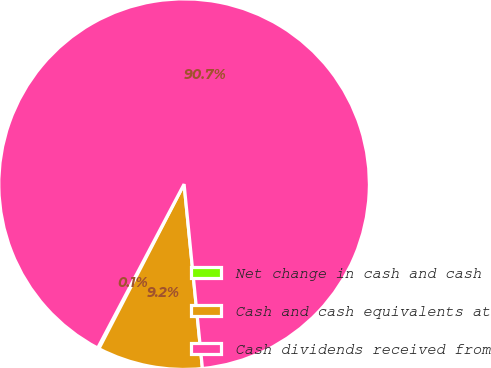Convert chart to OTSL. <chart><loc_0><loc_0><loc_500><loc_500><pie_chart><fcel>Net change in cash and cash<fcel>Cash and cash equivalents at<fcel>Cash dividends received from<nl><fcel>0.12%<fcel>9.18%<fcel>90.69%<nl></chart> 